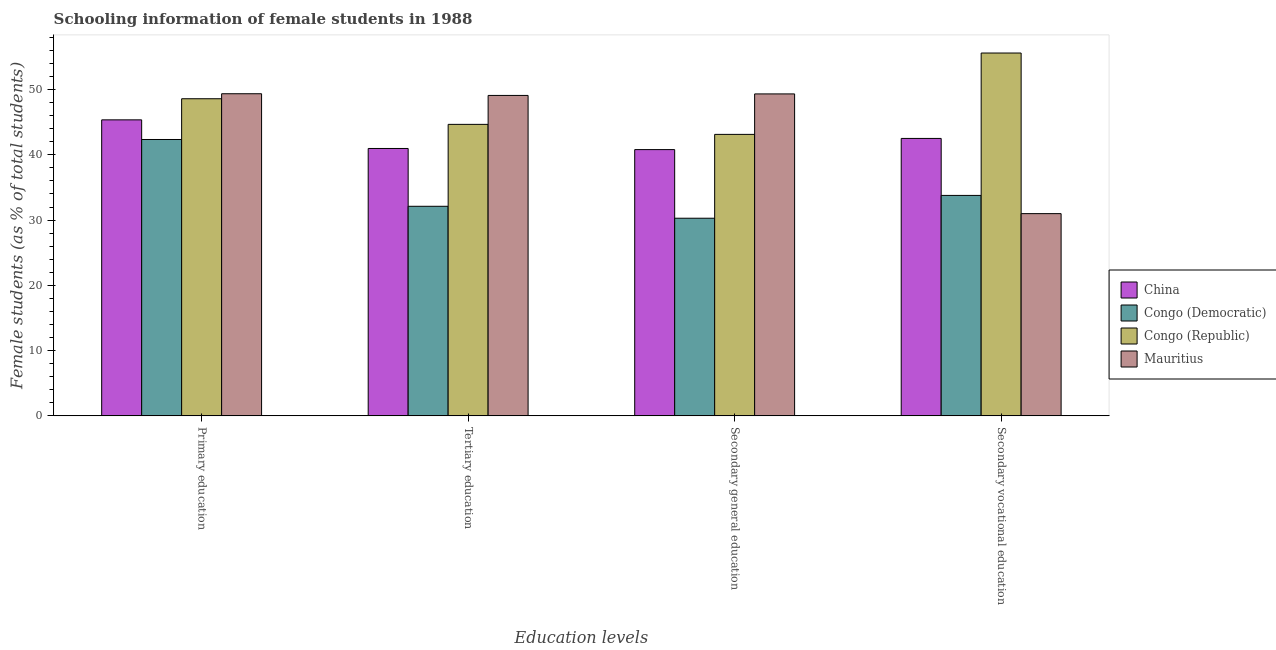How many different coloured bars are there?
Provide a short and direct response. 4. Are the number of bars per tick equal to the number of legend labels?
Your response must be concise. Yes. Are the number of bars on each tick of the X-axis equal?
Your answer should be very brief. Yes. How many bars are there on the 3rd tick from the left?
Provide a succinct answer. 4. What is the label of the 4th group of bars from the left?
Your answer should be compact. Secondary vocational education. What is the percentage of female students in secondary education in Congo (Republic)?
Offer a very short reply. 43.13. Across all countries, what is the maximum percentage of female students in secondary vocational education?
Offer a terse response. 55.6. Across all countries, what is the minimum percentage of female students in primary education?
Give a very brief answer. 42.34. In which country was the percentage of female students in secondary vocational education maximum?
Provide a short and direct response. Congo (Republic). In which country was the percentage of female students in secondary education minimum?
Provide a succinct answer. Congo (Democratic). What is the total percentage of female students in primary education in the graph?
Provide a short and direct response. 185.65. What is the difference between the percentage of female students in secondary vocational education in Mauritius and that in Congo (Republic)?
Your answer should be very brief. -24.61. What is the difference between the percentage of female students in secondary vocational education in Congo (Democratic) and the percentage of female students in secondary education in Congo (Republic)?
Give a very brief answer. -9.35. What is the average percentage of female students in primary education per country?
Your answer should be compact. 46.41. What is the difference between the percentage of female students in secondary vocational education and percentage of female students in secondary education in Mauritius?
Ensure brevity in your answer.  -18.34. What is the ratio of the percentage of female students in secondary education in Congo (Republic) to that in Congo (Democratic)?
Your response must be concise. 1.42. Is the percentage of female students in secondary education in Congo (Democratic) less than that in Congo (Republic)?
Ensure brevity in your answer.  Yes. What is the difference between the highest and the second highest percentage of female students in tertiary education?
Provide a succinct answer. 4.43. What is the difference between the highest and the lowest percentage of female students in primary education?
Provide a succinct answer. 7.01. In how many countries, is the percentage of female students in primary education greater than the average percentage of female students in primary education taken over all countries?
Your answer should be very brief. 2. Is the sum of the percentage of female students in secondary vocational education in Mauritius and Congo (Democratic) greater than the maximum percentage of female students in tertiary education across all countries?
Provide a short and direct response. Yes. What does the 3rd bar from the left in Secondary general education represents?
Offer a terse response. Congo (Republic). What does the 2nd bar from the right in Secondary general education represents?
Keep it short and to the point. Congo (Republic). How many bars are there?
Provide a succinct answer. 16. How many countries are there in the graph?
Your response must be concise. 4. What is the difference between two consecutive major ticks on the Y-axis?
Give a very brief answer. 10. Are the values on the major ticks of Y-axis written in scientific E-notation?
Give a very brief answer. No. Does the graph contain any zero values?
Your response must be concise. No. Does the graph contain grids?
Provide a short and direct response. No. How are the legend labels stacked?
Your response must be concise. Vertical. What is the title of the graph?
Give a very brief answer. Schooling information of female students in 1988. What is the label or title of the X-axis?
Your answer should be compact. Education levels. What is the label or title of the Y-axis?
Ensure brevity in your answer.  Female students (as % of total students). What is the Female students (as % of total students) of China in Primary education?
Make the answer very short. 45.36. What is the Female students (as % of total students) in Congo (Democratic) in Primary education?
Offer a terse response. 42.34. What is the Female students (as % of total students) in Congo (Republic) in Primary education?
Give a very brief answer. 48.59. What is the Female students (as % of total students) of Mauritius in Primary education?
Keep it short and to the point. 49.36. What is the Female students (as % of total students) in China in Tertiary education?
Offer a very short reply. 40.97. What is the Female students (as % of total students) in Congo (Democratic) in Tertiary education?
Your response must be concise. 32.11. What is the Female students (as % of total students) of Congo (Republic) in Tertiary education?
Provide a short and direct response. 44.66. What is the Female students (as % of total students) in Mauritius in Tertiary education?
Provide a succinct answer. 49.1. What is the Female students (as % of total students) of China in Secondary general education?
Give a very brief answer. 40.8. What is the Female students (as % of total students) in Congo (Democratic) in Secondary general education?
Your answer should be very brief. 30.28. What is the Female students (as % of total students) of Congo (Republic) in Secondary general education?
Provide a succinct answer. 43.13. What is the Female students (as % of total students) in Mauritius in Secondary general education?
Provide a short and direct response. 49.33. What is the Female students (as % of total students) in China in Secondary vocational education?
Ensure brevity in your answer.  42.51. What is the Female students (as % of total students) of Congo (Democratic) in Secondary vocational education?
Keep it short and to the point. 33.78. What is the Female students (as % of total students) of Congo (Republic) in Secondary vocational education?
Ensure brevity in your answer.  55.6. What is the Female students (as % of total students) in Mauritius in Secondary vocational education?
Make the answer very short. 30.99. Across all Education levels, what is the maximum Female students (as % of total students) of China?
Ensure brevity in your answer.  45.36. Across all Education levels, what is the maximum Female students (as % of total students) of Congo (Democratic)?
Your answer should be compact. 42.34. Across all Education levels, what is the maximum Female students (as % of total students) of Congo (Republic)?
Give a very brief answer. 55.6. Across all Education levels, what is the maximum Female students (as % of total students) in Mauritius?
Give a very brief answer. 49.36. Across all Education levels, what is the minimum Female students (as % of total students) in China?
Offer a terse response. 40.8. Across all Education levels, what is the minimum Female students (as % of total students) of Congo (Democratic)?
Ensure brevity in your answer.  30.28. Across all Education levels, what is the minimum Female students (as % of total students) of Congo (Republic)?
Your answer should be compact. 43.13. Across all Education levels, what is the minimum Female students (as % of total students) of Mauritius?
Your answer should be compact. 30.99. What is the total Female students (as % of total students) in China in the graph?
Offer a very short reply. 169.63. What is the total Female students (as % of total students) of Congo (Democratic) in the graph?
Your response must be concise. 138.51. What is the total Female students (as % of total students) in Congo (Republic) in the graph?
Offer a terse response. 191.98. What is the total Female students (as % of total students) in Mauritius in the graph?
Your response must be concise. 178.77. What is the difference between the Female students (as % of total students) in China in Primary education and that in Tertiary education?
Ensure brevity in your answer.  4.39. What is the difference between the Female students (as % of total students) of Congo (Democratic) in Primary education and that in Tertiary education?
Give a very brief answer. 10.23. What is the difference between the Female students (as % of total students) in Congo (Republic) in Primary education and that in Tertiary education?
Your response must be concise. 3.92. What is the difference between the Female students (as % of total students) of Mauritius in Primary education and that in Tertiary education?
Keep it short and to the point. 0.26. What is the difference between the Female students (as % of total students) of China in Primary education and that in Secondary general education?
Your response must be concise. 4.56. What is the difference between the Female students (as % of total students) in Congo (Democratic) in Primary education and that in Secondary general education?
Provide a short and direct response. 12.06. What is the difference between the Female students (as % of total students) in Congo (Republic) in Primary education and that in Secondary general education?
Make the answer very short. 5.46. What is the difference between the Female students (as % of total students) in Mauritius in Primary education and that in Secondary general education?
Offer a terse response. 0.03. What is the difference between the Female students (as % of total students) in China in Primary education and that in Secondary vocational education?
Make the answer very short. 2.85. What is the difference between the Female students (as % of total students) of Congo (Democratic) in Primary education and that in Secondary vocational education?
Offer a very short reply. 8.57. What is the difference between the Female students (as % of total students) in Congo (Republic) in Primary education and that in Secondary vocational education?
Give a very brief answer. -7.01. What is the difference between the Female students (as % of total students) of Mauritius in Primary education and that in Secondary vocational education?
Make the answer very short. 18.37. What is the difference between the Female students (as % of total students) of China in Tertiary education and that in Secondary general education?
Your answer should be compact. 0.17. What is the difference between the Female students (as % of total students) of Congo (Democratic) in Tertiary education and that in Secondary general education?
Give a very brief answer. 1.83. What is the difference between the Female students (as % of total students) in Congo (Republic) in Tertiary education and that in Secondary general education?
Your answer should be very brief. 1.54. What is the difference between the Female students (as % of total students) in Mauritius in Tertiary education and that in Secondary general education?
Your answer should be very brief. -0.23. What is the difference between the Female students (as % of total students) of China in Tertiary education and that in Secondary vocational education?
Your answer should be compact. -1.54. What is the difference between the Female students (as % of total students) of Congo (Democratic) in Tertiary education and that in Secondary vocational education?
Ensure brevity in your answer.  -1.67. What is the difference between the Female students (as % of total students) of Congo (Republic) in Tertiary education and that in Secondary vocational education?
Keep it short and to the point. -10.93. What is the difference between the Female students (as % of total students) of Mauritius in Tertiary education and that in Secondary vocational education?
Give a very brief answer. 18.11. What is the difference between the Female students (as % of total students) of China in Secondary general education and that in Secondary vocational education?
Provide a short and direct response. -1.71. What is the difference between the Female students (as % of total students) of Congo (Democratic) in Secondary general education and that in Secondary vocational education?
Make the answer very short. -3.5. What is the difference between the Female students (as % of total students) of Congo (Republic) in Secondary general education and that in Secondary vocational education?
Your answer should be compact. -12.47. What is the difference between the Female students (as % of total students) in Mauritius in Secondary general education and that in Secondary vocational education?
Your answer should be compact. 18.34. What is the difference between the Female students (as % of total students) in China in Primary education and the Female students (as % of total students) in Congo (Democratic) in Tertiary education?
Give a very brief answer. 13.24. What is the difference between the Female students (as % of total students) in China in Primary education and the Female students (as % of total students) in Congo (Republic) in Tertiary education?
Make the answer very short. 0.69. What is the difference between the Female students (as % of total students) in China in Primary education and the Female students (as % of total students) in Mauritius in Tertiary education?
Provide a short and direct response. -3.74. What is the difference between the Female students (as % of total students) in Congo (Democratic) in Primary education and the Female students (as % of total students) in Congo (Republic) in Tertiary education?
Ensure brevity in your answer.  -2.32. What is the difference between the Female students (as % of total students) of Congo (Democratic) in Primary education and the Female students (as % of total students) of Mauritius in Tertiary education?
Keep it short and to the point. -6.75. What is the difference between the Female students (as % of total students) in Congo (Republic) in Primary education and the Female students (as % of total students) in Mauritius in Tertiary education?
Offer a very short reply. -0.51. What is the difference between the Female students (as % of total students) in China in Primary education and the Female students (as % of total students) in Congo (Democratic) in Secondary general education?
Ensure brevity in your answer.  15.07. What is the difference between the Female students (as % of total students) in China in Primary education and the Female students (as % of total students) in Congo (Republic) in Secondary general education?
Ensure brevity in your answer.  2.23. What is the difference between the Female students (as % of total students) in China in Primary education and the Female students (as % of total students) in Mauritius in Secondary general education?
Provide a succinct answer. -3.97. What is the difference between the Female students (as % of total students) of Congo (Democratic) in Primary education and the Female students (as % of total students) of Congo (Republic) in Secondary general education?
Ensure brevity in your answer.  -0.78. What is the difference between the Female students (as % of total students) in Congo (Democratic) in Primary education and the Female students (as % of total students) in Mauritius in Secondary general education?
Provide a short and direct response. -6.98. What is the difference between the Female students (as % of total students) in Congo (Republic) in Primary education and the Female students (as % of total students) in Mauritius in Secondary general education?
Your response must be concise. -0.74. What is the difference between the Female students (as % of total students) in China in Primary education and the Female students (as % of total students) in Congo (Democratic) in Secondary vocational education?
Your response must be concise. 11.58. What is the difference between the Female students (as % of total students) of China in Primary education and the Female students (as % of total students) of Congo (Republic) in Secondary vocational education?
Your response must be concise. -10.24. What is the difference between the Female students (as % of total students) of China in Primary education and the Female students (as % of total students) of Mauritius in Secondary vocational education?
Offer a terse response. 14.37. What is the difference between the Female students (as % of total students) in Congo (Democratic) in Primary education and the Female students (as % of total students) in Congo (Republic) in Secondary vocational education?
Give a very brief answer. -13.25. What is the difference between the Female students (as % of total students) of Congo (Democratic) in Primary education and the Female students (as % of total students) of Mauritius in Secondary vocational education?
Your answer should be compact. 11.36. What is the difference between the Female students (as % of total students) of Congo (Republic) in Primary education and the Female students (as % of total students) of Mauritius in Secondary vocational education?
Your response must be concise. 17.6. What is the difference between the Female students (as % of total students) of China in Tertiary education and the Female students (as % of total students) of Congo (Democratic) in Secondary general education?
Your answer should be compact. 10.69. What is the difference between the Female students (as % of total students) of China in Tertiary education and the Female students (as % of total students) of Congo (Republic) in Secondary general education?
Make the answer very short. -2.16. What is the difference between the Female students (as % of total students) in China in Tertiary education and the Female students (as % of total students) in Mauritius in Secondary general education?
Offer a terse response. -8.36. What is the difference between the Female students (as % of total students) of Congo (Democratic) in Tertiary education and the Female students (as % of total students) of Congo (Republic) in Secondary general education?
Give a very brief answer. -11.02. What is the difference between the Female students (as % of total students) of Congo (Democratic) in Tertiary education and the Female students (as % of total students) of Mauritius in Secondary general education?
Ensure brevity in your answer.  -17.22. What is the difference between the Female students (as % of total students) in Congo (Republic) in Tertiary education and the Female students (as % of total students) in Mauritius in Secondary general education?
Provide a succinct answer. -4.67. What is the difference between the Female students (as % of total students) in China in Tertiary education and the Female students (as % of total students) in Congo (Democratic) in Secondary vocational education?
Your answer should be very brief. 7.19. What is the difference between the Female students (as % of total students) of China in Tertiary education and the Female students (as % of total students) of Congo (Republic) in Secondary vocational education?
Your answer should be very brief. -14.63. What is the difference between the Female students (as % of total students) of China in Tertiary education and the Female students (as % of total students) of Mauritius in Secondary vocational education?
Offer a terse response. 9.98. What is the difference between the Female students (as % of total students) of Congo (Democratic) in Tertiary education and the Female students (as % of total students) of Congo (Republic) in Secondary vocational education?
Your answer should be compact. -23.48. What is the difference between the Female students (as % of total students) of Congo (Democratic) in Tertiary education and the Female students (as % of total students) of Mauritius in Secondary vocational education?
Ensure brevity in your answer.  1.12. What is the difference between the Female students (as % of total students) in Congo (Republic) in Tertiary education and the Female students (as % of total students) in Mauritius in Secondary vocational education?
Your answer should be very brief. 13.68. What is the difference between the Female students (as % of total students) of China in Secondary general education and the Female students (as % of total students) of Congo (Democratic) in Secondary vocational education?
Provide a succinct answer. 7.02. What is the difference between the Female students (as % of total students) in China in Secondary general education and the Female students (as % of total students) in Congo (Republic) in Secondary vocational education?
Ensure brevity in your answer.  -14.8. What is the difference between the Female students (as % of total students) in China in Secondary general education and the Female students (as % of total students) in Mauritius in Secondary vocational education?
Offer a terse response. 9.81. What is the difference between the Female students (as % of total students) in Congo (Democratic) in Secondary general education and the Female students (as % of total students) in Congo (Republic) in Secondary vocational education?
Offer a terse response. -25.31. What is the difference between the Female students (as % of total students) in Congo (Democratic) in Secondary general education and the Female students (as % of total students) in Mauritius in Secondary vocational education?
Your answer should be compact. -0.71. What is the difference between the Female students (as % of total students) of Congo (Republic) in Secondary general education and the Female students (as % of total students) of Mauritius in Secondary vocational education?
Offer a very short reply. 12.14. What is the average Female students (as % of total students) of China per Education levels?
Offer a terse response. 42.41. What is the average Female students (as % of total students) in Congo (Democratic) per Education levels?
Offer a terse response. 34.63. What is the average Female students (as % of total students) of Congo (Republic) per Education levels?
Give a very brief answer. 47.99. What is the average Female students (as % of total students) of Mauritius per Education levels?
Keep it short and to the point. 44.69. What is the difference between the Female students (as % of total students) in China and Female students (as % of total students) in Congo (Democratic) in Primary education?
Keep it short and to the point. 3.01. What is the difference between the Female students (as % of total students) of China and Female students (as % of total students) of Congo (Republic) in Primary education?
Make the answer very short. -3.23. What is the difference between the Female students (as % of total students) in China and Female students (as % of total students) in Mauritius in Primary education?
Provide a succinct answer. -4. What is the difference between the Female students (as % of total students) of Congo (Democratic) and Female students (as % of total students) of Congo (Republic) in Primary education?
Ensure brevity in your answer.  -6.24. What is the difference between the Female students (as % of total students) of Congo (Democratic) and Female students (as % of total students) of Mauritius in Primary education?
Offer a very short reply. -7.01. What is the difference between the Female students (as % of total students) of Congo (Republic) and Female students (as % of total students) of Mauritius in Primary education?
Make the answer very short. -0.77. What is the difference between the Female students (as % of total students) of China and Female students (as % of total students) of Congo (Democratic) in Tertiary education?
Offer a very short reply. 8.86. What is the difference between the Female students (as % of total students) in China and Female students (as % of total students) in Congo (Republic) in Tertiary education?
Offer a terse response. -3.69. What is the difference between the Female students (as % of total students) of China and Female students (as % of total students) of Mauritius in Tertiary education?
Make the answer very short. -8.13. What is the difference between the Female students (as % of total students) in Congo (Democratic) and Female students (as % of total students) in Congo (Republic) in Tertiary education?
Offer a terse response. -12.55. What is the difference between the Female students (as % of total students) in Congo (Democratic) and Female students (as % of total students) in Mauritius in Tertiary education?
Offer a very short reply. -16.98. What is the difference between the Female students (as % of total students) in Congo (Republic) and Female students (as % of total students) in Mauritius in Tertiary education?
Offer a very short reply. -4.43. What is the difference between the Female students (as % of total students) in China and Female students (as % of total students) in Congo (Democratic) in Secondary general education?
Provide a short and direct response. 10.51. What is the difference between the Female students (as % of total students) in China and Female students (as % of total students) in Congo (Republic) in Secondary general education?
Provide a short and direct response. -2.33. What is the difference between the Female students (as % of total students) in China and Female students (as % of total students) in Mauritius in Secondary general education?
Provide a succinct answer. -8.53. What is the difference between the Female students (as % of total students) of Congo (Democratic) and Female students (as % of total students) of Congo (Republic) in Secondary general education?
Your response must be concise. -12.85. What is the difference between the Female students (as % of total students) of Congo (Democratic) and Female students (as % of total students) of Mauritius in Secondary general education?
Provide a succinct answer. -19.05. What is the difference between the Female students (as % of total students) in Congo (Republic) and Female students (as % of total students) in Mauritius in Secondary general education?
Make the answer very short. -6.2. What is the difference between the Female students (as % of total students) of China and Female students (as % of total students) of Congo (Democratic) in Secondary vocational education?
Offer a very short reply. 8.73. What is the difference between the Female students (as % of total students) in China and Female students (as % of total students) in Congo (Republic) in Secondary vocational education?
Your answer should be very brief. -13.09. What is the difference between the Female students (as % of total students) in China and Female students (as % of total students) in Mauritius in Secondary vocational education?
Offer a terse response. 11.52. What is the difference between the Female students (as % of total students) in Congo (Democratic) and Female students (as % of total students) in Congo (Republic) in Secondary vocational education?
Make the answer very short. -21.82. What is the difference between the Female students (as % of total students) of Congo (Democratic) and Female students (as % of total students) of Mauritius in Secondary vocational education?
Give a very brief answer. 2.79. What is the difference between the Female students (as % of total students) in Congo (Republic) and Female students (as % of total students) in Mauritius in Secondary vocational education?
Provide a short and direct response. 24.61. What is the ratio of the Female students (as % of total students) in China in Primary education to that in Tertiary education?
Ensure brevity in your answer.  1.11. What is the ratio of the Female students (as % of total students) in Congo (Democratic) in Primary education to that in Tertiary education?
Provide a succinct answer. 1.32. What is the ratio of the Female students (as % of total students) of Congo (Republic) in Primary education to that in Tertiary education?
Give a very brief answer. 1.09. What is the ratio of the Female students (as % of total students) of China in Primary education to that in Secondary general education?
Your answer should be very brief. 1.11. What is the ratio of the Female students (as % of total students) of Congo (Democratic) in Primary education to that in Secondary general education?
Your answer should be compact. 1.4. What is the ratio of the Female students (as % of total students) in Congo (Republic) in Primary education to that in Secondary general education?
Offer a very short reply. 1.13. What is the ratio of the Female students (as % of total students) of Mauritius in Primary education to that in Secondary general education?
Provide a short and direct response. 1. What is the ratio of the Female students (as % of total students) of China in Primary education to that in Secondary vocational education?
Give a very brief answer. 1.07. What is the ratio of the Female students (as % of total students) in Congo (Democratic) in Primary education to that in Secondary vocational education?
Ensure brevity in your answer.  1.25. What is the ratio of the Female students (as % of total students) of Congo (Republic) in Primary education to that in Secondary vocational education?
Make the answer very short. 0.87. What is the ratio of the Female students (as % of total students) in Mauritius in Primary education to that in Secondary vocational education?
Your response must be concise. 1.59. What is the ratio of the Female students (as % of total students) in Congo (Democratic) in Tertiary education to that in Secondary general education?
Ensure brevity in your answer.  1.06. What is the ratio of the Female students (as % of total students) of Congo (Republic) in Tertiary education to that in Secondary general education?
Provide a short and direct response. 1.04. What is the ratio of the Female students (as % of total students) in China in Tertiary education to that in Secondary vocational education?
Provide a short and direct response. 0.96. What is the ratio of the Female students (as % of total students) in Congo (Democratic) in Tertiary education to that in Secondary vocational education?
Give a very brief answer. 0.95. What is the ratio of the Female students (as % of total students) in Congo (Republic) in Tertiary education to that in Secondary vocational education?
Offer a very short reply. 0.8. What is the ratio of the Female students (as % of total students) of Mauritius in Tertiary education to that in Secondary vocational education?
Give a very brief answer. 1.58. What is the ratio of the Female students (as % of total students) of China in Secondary general education to that in Secondary vocational education?
Your answer should be compact. 0.96. What is the ratio of the Female students (as % of total students) in Congo (Democratic) in Secondary general education to that in Secondary vocational education?
Provide a succinct answer. 0.9. What is the ratio of the Female students (as % of total students) of Congo (Republic) in Secondary general education to that in Secondary vocational education?
Give a very brief answer. 0.78. What is the ratio of the Female students (as % of total students) in Mauritius in Secondary general education to that in Secondary vocational education?
Your answer should be compact. 1.59. What is the difference between the highest and the second highest Female students (as % of total students) in China?
Offer a terse response. 2.85. What is the difference between the highest and the second highest Female students (as % of total students) of Congo (Democratic)?
Provide a succinct answer. 8.57. What is the difference between the highest and the second highest Female students (as % of total students) in Congo (Republic)?
Offer a very short reply. 7.01. What is the difference between the highest and the second highest Female students (as % of total students) of Mauritius?
Ensure brevity in your answer.  0.03. What is the difference between the highest and the lowest Female students (as % of total students) in China?
Ensure brevity in your answer.  4.56. What is the difference between the highest and the lowest Female students (as % of total students) of Congo (Democratic)?
Your response must be concise. 12.06. What is the difference between the highest and the lowest Female students (as % of total students) in Congo (Republic)?
Provide a short and direct response. 12.47. What is the difference between the highest and the lowest Female students (as % of total students) of Mauritius?
Offer a very short reply. 18.37. 